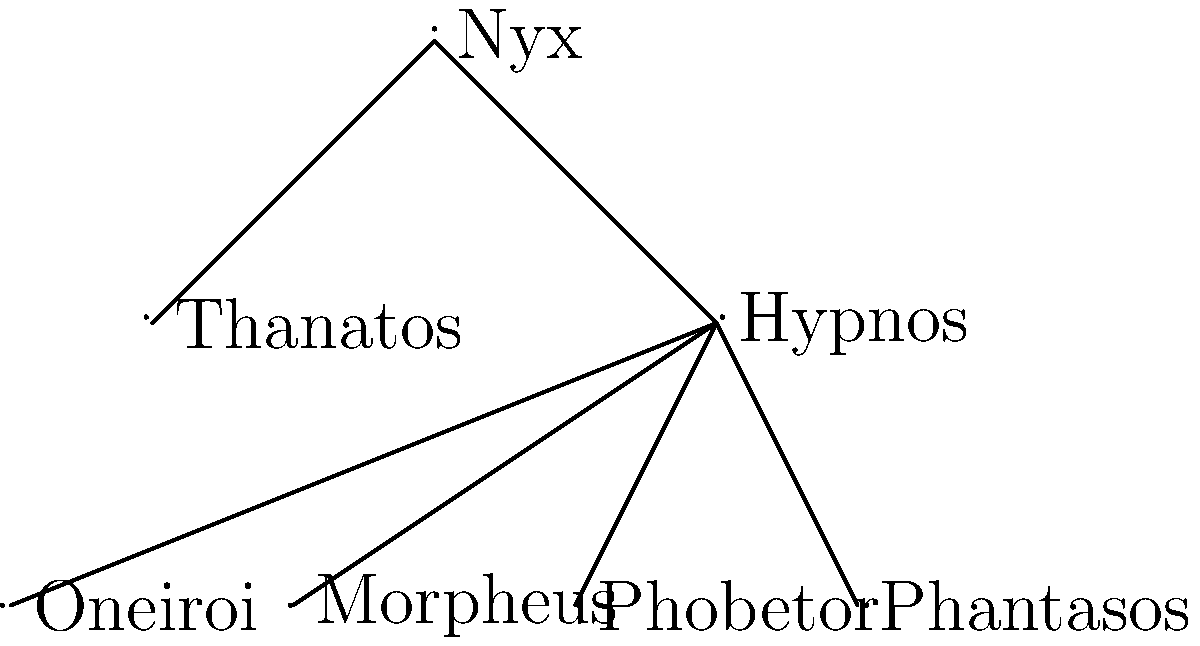In this family tree of lesser-known Greek mythological figures, which character would be most suitable as a modern superhero with the power to manipulate dreams and nightmares? To answer this question, let's analyze the family tree and the roles of each figure:

1. Nyx: The goddess of night, parent to Thanatos and Hypnos.
2. Thanatos: The personification of death, not directly related to dreams.
3. Hypnos: The god of sleep, parent to the dream-related deities.
4. Oneiroi: The collective name for dream spirits.
5. Morpheus: The god of dreams, specifically those involving human shapes.
6. Phobetor: The god of nightmares, particularly those involving animals.
7. Phantasos: The god of surreal dreams, involving inanimate objects or fantastical scenarios.

For a modern superhero with the power to manipulate dreams and nightmares, we need a character with a broad range of dream-related abilities. While Morpheus, Phobetor, and Phantasos each have specific dream-related powers, their father Hypnos oversees all aspects of sleep and dreaming.

Hypnos, as the god of sleep and parent to the dream gods, would have the most comprehensive understanding and control over various types of dreams and nightmares. This makes him the most suitable candidate for a modern superhero with dream manipulation powers, as he could potentially tap into all aspects of dreaming, from pleasant dreams to nightmares and surreal visions.
Answer: Hypnos 